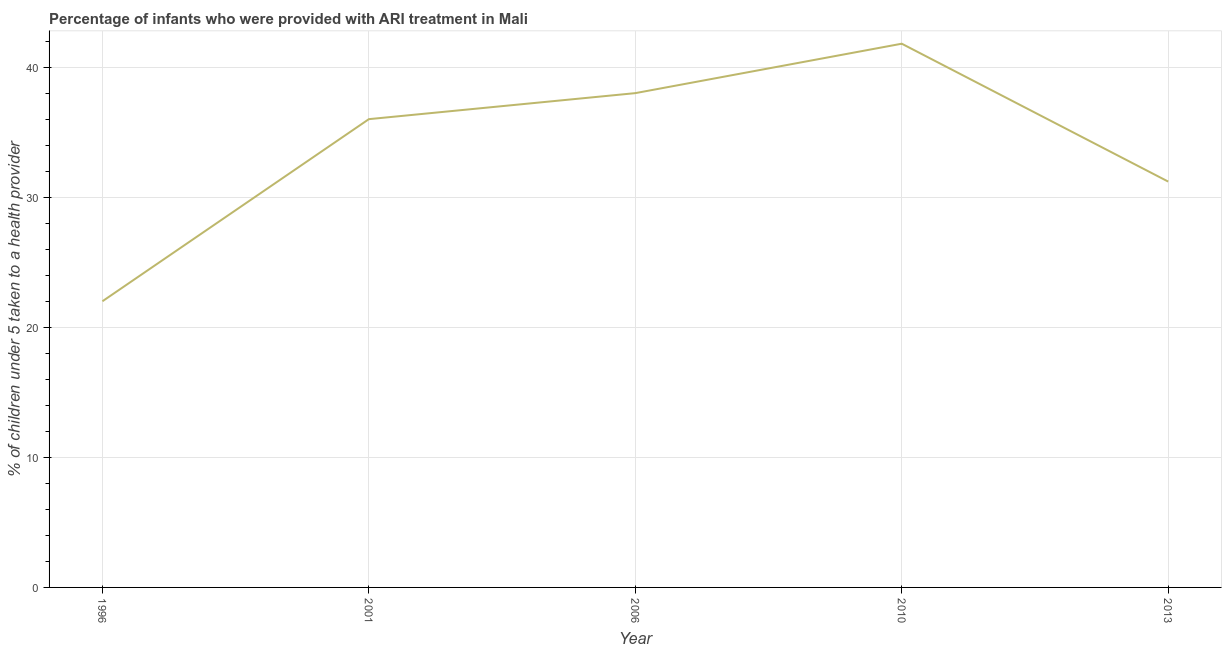What is the percentage of children who were provided with ari treatment in 2001?
Offer a terse response. 36. Across all years, what is the maximum percentage of children who were provided with ari treatment?
Keep it short and to the point. 41.8. Across all years, what is the minimum percentage of children who were provided with ari treatment?
Give a very brief answer. 22. In which year was the percentage of children who were provided with ari treatment minimum?
Keep it short and to the point. 1996. What is the sum of the percentage of children who were provided with ari treatment?
Make the answer very short. 169. What is the difference between the percentage of children who were provided with ari treatment in 1996 and 2006?
Offer a terse response. -16. What is the average percentage of children who were provided with ari treatment per year?
Ensure brevity in your answer.  33.8. Do a majority of the years between 2013 and 1996 (inclusive) have percentage of children who were provided with ari treatment greater than 14 %?
Your answer should be very brief. Yes. What is the ratio of the percentage of children who were provided with ari treatment in 2006 to that in 2013?
Make the answer very short. 1.22. Is the difference between the percentage of children who were provided with ari treatment in 2006 and 2013 greater than the difference between any two years?
Make the answer very short. No. What is the difference between the highest and the second highest percentage of children who were provided with ari treatment?
Your answer should be very brief. 3.8. Is the sum of the percentage of children who were provided with ari treatment in 2006 and 2013 greater than the maximum percentage of children who were provided with ari treatment across all years?
Your answer should be compact. Yes. What is the difference between the highest and the lowest percentage of children who were provided with ari treatment?
Your response must be concise. 19.8. In how many years, is the percentage of children who were provided with ari treatment greater than the average percentage of children who were provided with ari treatment taken over all years?
Offer a terse response. 3. Does the percentage of children who were provided with ari treatment monotonically increase over the years?
Make the answer very short. No. How many lines are there?
Give a very brief answer. 1. How many years are there in the graph?
Offer a very short reply. 5. Are the values on the major ticks of Y-axis written in scientific E-notation?
Your response must be concise. No. Does the graph contain grids?
Your answer should be very brief. Yes. What is the title of the graph?
Make the answer very short. Percentage of infants who were provided with ARI treatment in Mali. What is the label or title of the Y-axis?
Your response must be concise. % of children under 5 taken to a health provider. What is the % of children under 5 taken to a health provider of 1996?
Your answer should be compact. 22. What is the % of children under 5 taken to a health provider in 2001?
Offer a very short reply. 36. What is the % of children under 5 taken to a health provider in 2010?
Your response must be concise. 41.8. What is the % of children under 5 taken to a health provider of 2013?
Your answer should be compact. 31.2. What is the difference between the % of children under 5 taken to a health provider in 1996 and 2010?
Provide a short and direct response. -19.8. What is the difference between the % of children under 5 taken to a health provider in 1996 and 2013?
Offer a very short reply. -9.2. What is the difference between the % of children under 5 taken to a health provider in 2006 and 2010?
Give a very brief answer. -3.8. What is the difference between the % of children under 5 taken to a health provider in 2010 and 2013?
Offer a very short reply. 10.6. What is the ratio of the % of children under 5 taken to a health provider in 1996 to that in 2001?
Offer a terse response. 0.61. What is the ratio of the % of children under 5 taken to a health provider in 1996 to that in 2006?
Provide a succinct answer. 0.58. What is the ratio of the % of children under 5 taken to a health provider in 1996 to that in 2010?
Offer a terse response. 0.53. What is the ratio of the % of children under 5 taken to a health provider in 1996 to that in 2013?
Your answer should be compact. 0.7. What is the ratio of the % of children under 5 taken to a health provider in 2001 to that in 2006?
Keep it short and to the point. 0.95. What is the ratio of the % of children under 5 taken to a health provider in 2001 to that in 2010?
Make the answer very short. 0.86. What is the ratio of the % of children under 5 taken to a health provider in 2001 to that in 2013?
Provide a succinct answer. 1.15. What is the ratio of the % of children under 5 taken to a health provider in 2006 to that in 2010?
Give a very brief answer. 0.91. What is the ratio of the % of children under 5 taken to a health provider in 2006 to that in 2013?
Keep it short and to the point. 1.22. What is the ratio of the % of children under 5 taken to a health provider in 2010 to that in 2013?
Your response must be concise. 1.34. 